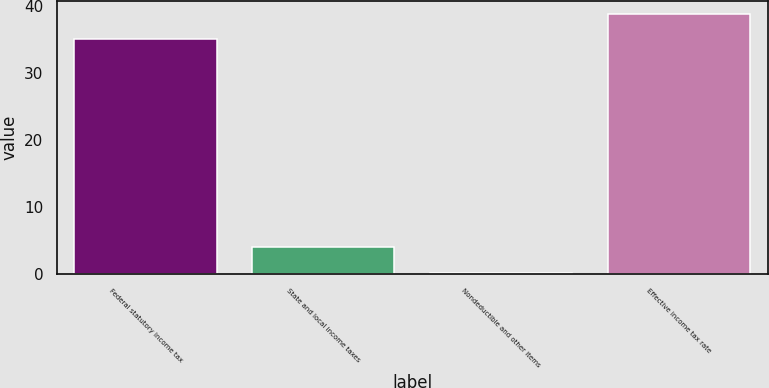Convert chart to OTSL. <chart><loc_0><loc_0><loc_500><loc_500><bar_chart><fcel>Federal statutory income tax<fcel>State and local income taxes<fcel>Nondeductible and other items<fcel>Effective income tax rate<nl><fcel>35<fcel>3.98<fcel>0.2<fcel>38.78<nl></chart> 